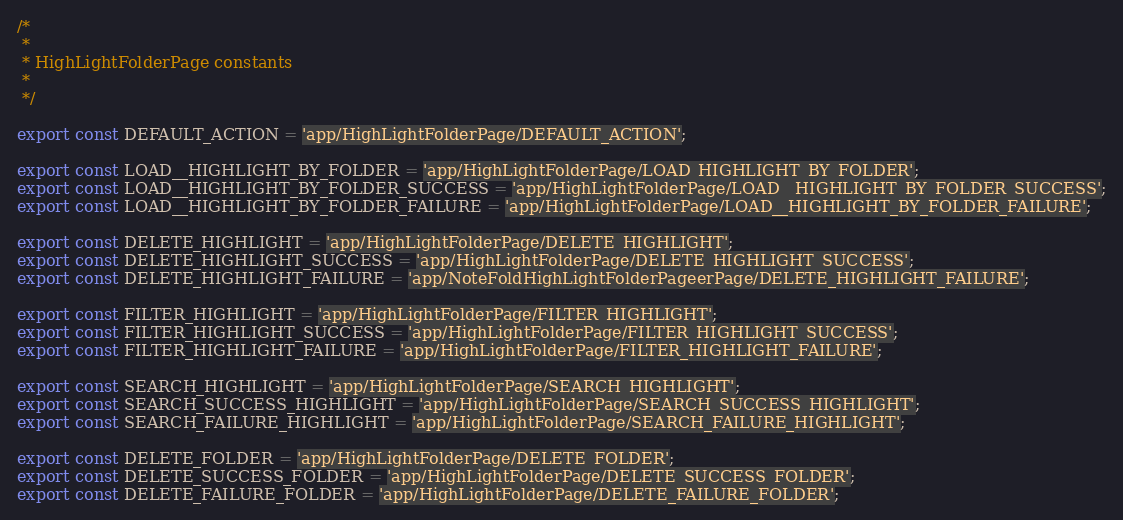Convert code to text. <code><loc_0><loc_0><loc_500><loc_500><_JavaScript_>/*
 *
 * HighLightFolderPage constants
 *
 */

export const DEFAULT_ACTION = 'app/HighLightFolderPage/DEFAULT_ACTION';

export const LOAD__HIGHLIGHT_BY_FOLDER = 'app/HighLightFolderPage/LOAD_HIGHLIGHT_BY_FOLDER';
export const LOAD__HIGHLIGHT_BY_FOLDER_SUCCESS = 'app/HighLightFolderPage/LOAD__HIGHLIGHT_BY_FOLDER_SUCCESS';
export const LOAD__HIGHLIGHT_BY_FOLDER_FAILURE = 'app/HighLightFolderPage/LOAD__HIGHLIGHT_BY_FOLDER_FAILURE';

export const DELETE_HIGHLIGHT = 'app/HighLightFolderPage/DELETE_HIGHLIGHT';
export const DELETE_HIGHLIGHT_SUCCESS = 'app/HighLightFolderPage/DELETE_HIGHLIGHT_SUCCESS';
export const DELETE_HIGHLIGHT_FAILURE = 'app/NoteFoldHighLightFolderPageerPage/DELETE_HIGHLIGHT_FAILURE';

export const FILTER_HIGHLIGHT = 'app/HighLightFolderPage/FILTER_HIGHLIGHT';
export const FILTER_HIGHLIGHT_SUCCESS = 'app/HighLightFolderPage/FILTER_HIGHLIGHT_SUCCESS';
export const FILTER_HIGHLIGHT_FAILURE = 'app/HighLightFolderPage/FILTER_HIGHLIGHT_FAILURE';

export const SEARCH_HIGHLIGHT = 'app/HighLightFolderPage/SEARCH_HIGHLIGHT';
export const SEARCH_SUCCESS_HIGHLIGHT = 'app/HighLightFolderPage/SEARCH_SUCCESS_HIGHLIGHT';
export const SEARCH_FAILURE_HIGHLIGHT = 'app/HighLightFolderPage/SEARCH_FAILURE_HIGHLIGHT';

export const DELETE_FOLDER = 'app/HighLightFolderPage/DELETE_FOLDER';
export const DELETE_SUCCESS_FOLDER = 'app/HighLightFolderPage/DELETE_SUCCESS_FOLDER';
export const DELETE_FAILURE_FOLDER = 'app/HighLightFolderPage/DELETE_FAILURE_FOLDER';</code> 